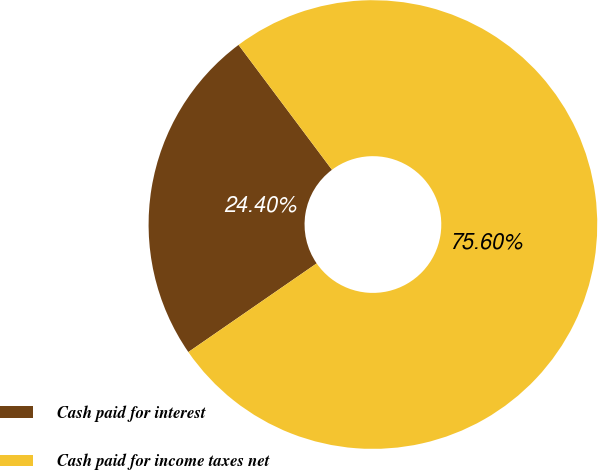Convert chart. <chart><loc_0><loc_0><loc_500><loc_500><pie_chart><fcel>Cash paid for interest<fcel>Cash paid for income taxes net<nl><fcel>24.4%<fcel>75.6%<nl></chart> 